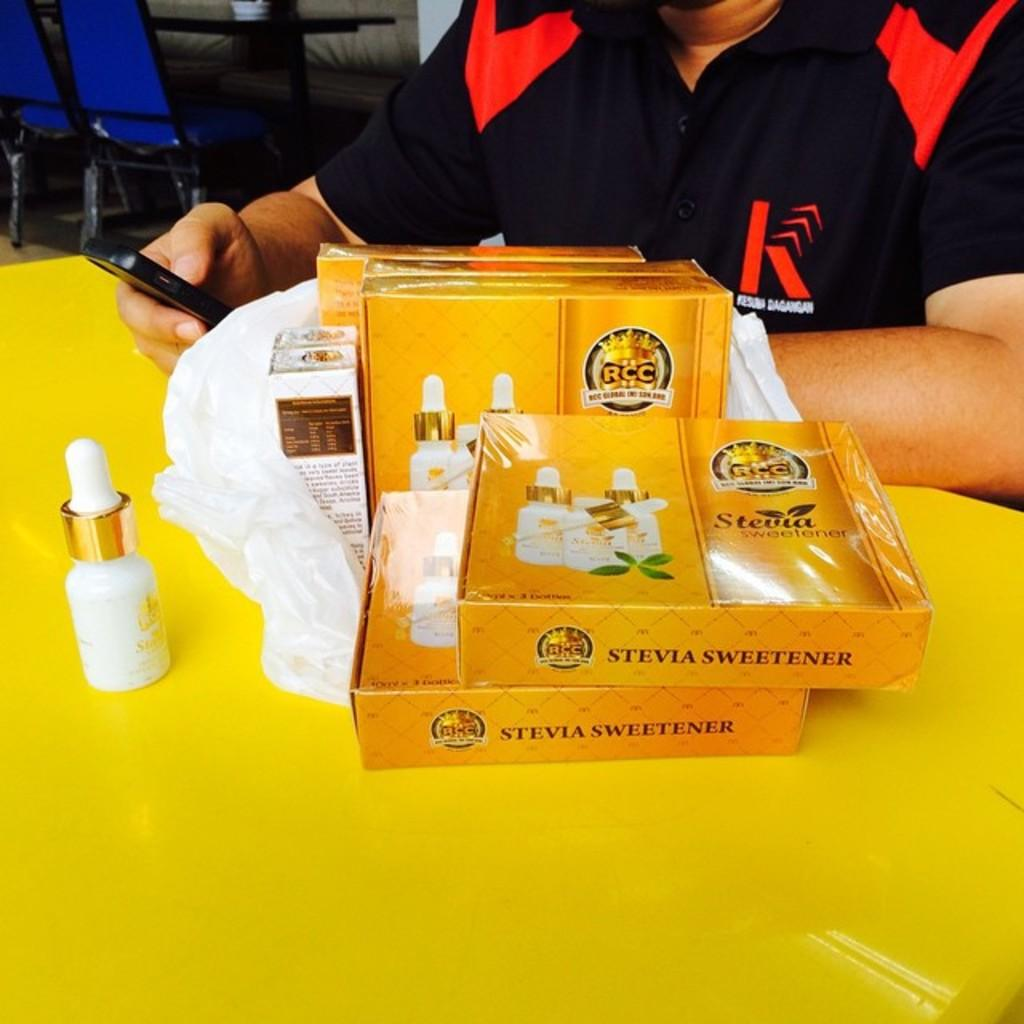<image>
Provide a brief description of the given image. A man sits at a table several boxes of Stevia sweetner. 